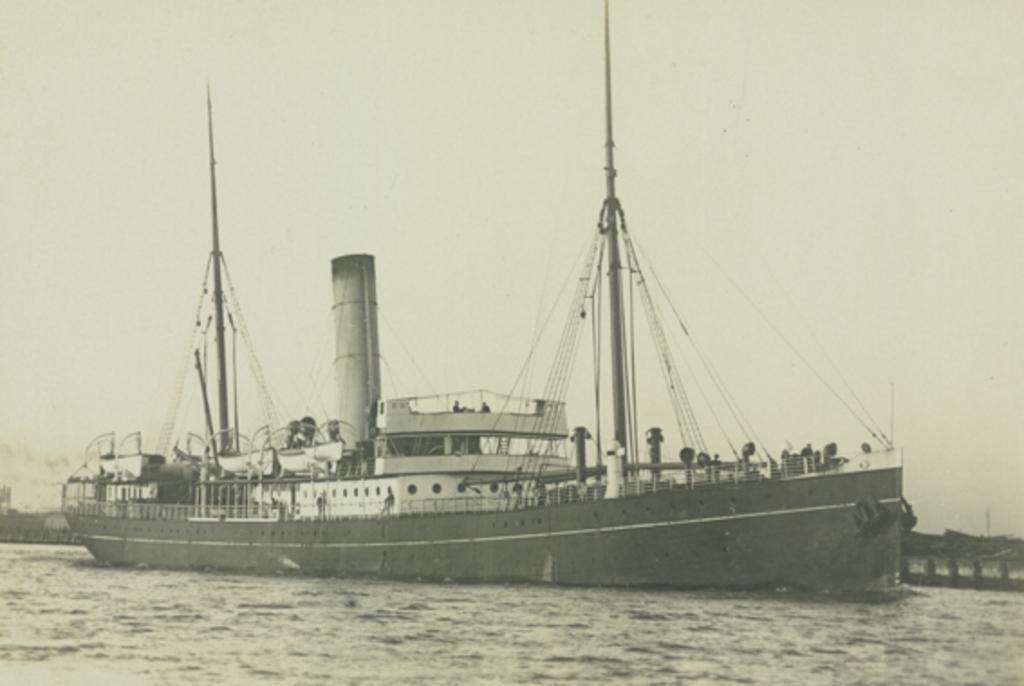What is the main subject of the image? The main subject of the image is a boat. Where is the boat located in the image? The boat is on water in the image. What can be seen in the background of the image? The sky is visible in the background of the image. What type of hobbies can be seen being practiced by the boat in the image? There are no hobbies being practiced by the boat in the image; it is simply floating on water. How many steps are visible in the image? There are no steps visible in the image. Is there a chain attached to the boat in the image? There is no chain attached to the boat in the image. 